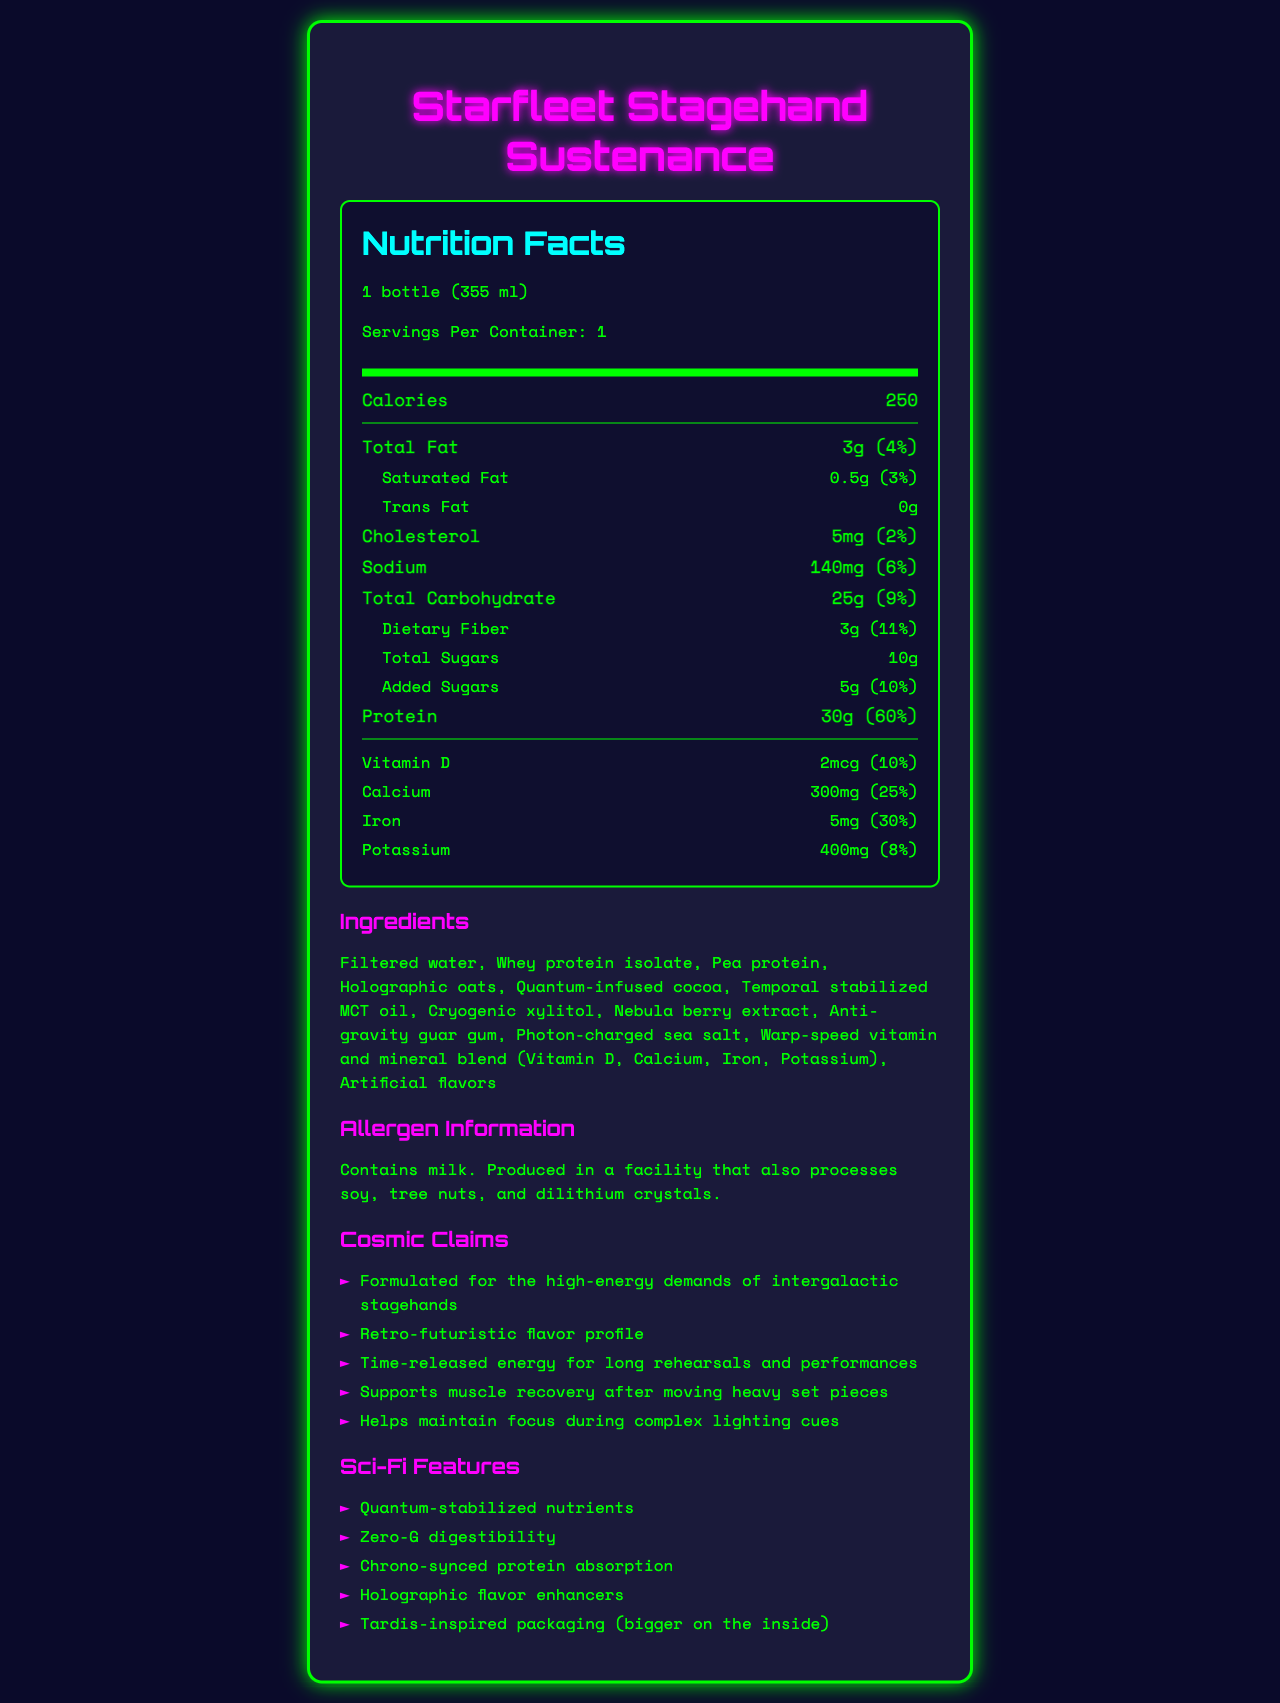what is the serving size of Starfleet Stagehand Sustenance? The serving size is explicitly mentioned at the beginning of the nutrition label as "1 bottle (355 ml)".
Answer: 1 bottle (355 ml) how many calories does one serving contain? The number of calories per serving is stated in the main nutrition information section as "Calories 250".
Answer: 250 what is the total fat content per serving? The total fat content is listed in the nutrition facts as "Total Fat 3g".
Answer: 3g how much protein does one serving provide? The protein content per serving is provided in the nutrition facts as "Protein 30g".
Answer: 30g what is the daily value percentage of calcium provided by the protein shake? The daily value percentage of calcium is mentioned under the Vitamin and Mineral information as "Calcium 300mg (25%)".
Answer: 25% does the product contain any trans fat? The nutrition information explicitly lists "Trans Fat 0g".
Answer: No which of the following ingredients is NOT found in Starfleet Stagehand Sustenance? 
A. Nebula berry extract 
B. Cryogenic xylitol 
C. Galactic sugar 
D. Photon-charged sea salt The listed ingredients include "Nebula berry extract", "Cryogenic xylitol", and "Photon-charged sea salt" but do not mention "Galactic sugar".
Answer: C what is unique about the energy release in this protein shake? 
A. Instant energy boost 
B. Time-released energy 
C. No energy release 
D. Only for short-term energy The marketing claims section describes "Time-released energy for long rehearsals and performances".
Answer: B does the product support muscle recovery after moving heavy set pieces? The marketing claims include: "Supports muscle recovery after moving heavy set pieces".
Answer: Yes how is the packaging of the product described? In the sci-fi features, one item is "Tardis-inspired packaging (bigger on the inside)".
Answer: Tardis-inspired packaging (bigger on the inside) summarize the main features and benefits of Starfleet Stagehand Sustenance. The summary captures the comprehensive product characteristics, including nutritional content, sci-fi features, and marketing claims.
Answer: Starfleet Stagehand Sustenance is a sci-fi themed protein shake designed for stagehands and crew members. It provides 250 calories per serving, with significant amounts of protein (30g) and key nutrients like calcium, iron, and potassium. The product also features unique sci-fi elements such as quantum-stabilized nutrients and chrono-synced protein absorption. It supports high-energy demands, muscle recovery, and focus during performances. The allergen information notes the presence of milk and potential cross-contamination with soy, tree nuts, and dilithium crystals. what is the source of calcium in the protein shake? The document does not provide information on the specific source of calcium; it only lists the nutrient content.
Answer: Not enough information 